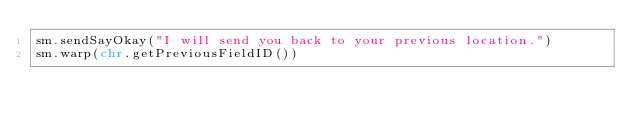Convert code to text. <code><loc_0><loc_0><loc_500><loc_500><_Python_>sm.sendSayOkay("I will send you back to your previous location.")
sm.warp(chr.getPreviousFieldID())</code> 